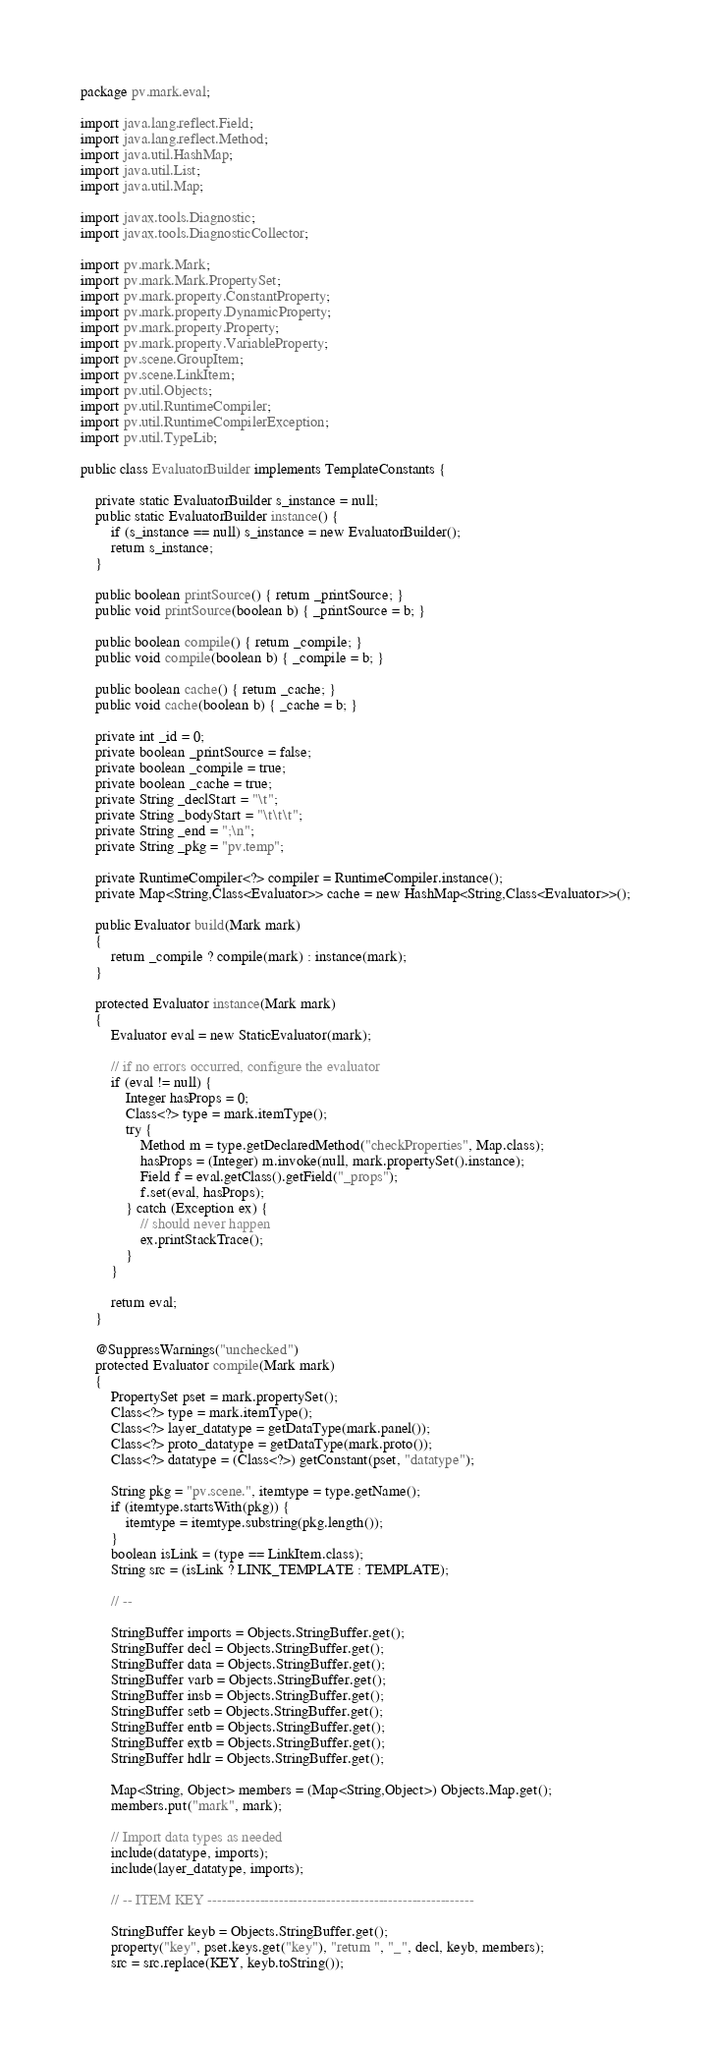Convert code to text. <code><loc_0><loc_0><loc_500><loc_500><_Java_>package pv.mark.eval;

import java.lang.reflect.Field;
import java.lang.reflect.Method;
import java.util.HashMap;
import java.util.List;
import java.util.Map;

import javax.tools.Diagnostic;
import javax.tools.DiagnosticCollector;

import pv.mark.Mark;
import pv.mark.Mark.PropertySet;
import pv.mark.property.ConstantProperty;
import pv.mark.property.DynamicProperty;
import pv.mark.property.Property;
import pv.mark.property.VariableProperty;
import pv.scene.GroupItem;
import pv.scene.LinkItem;
import pv.util.Objects;
import pv.util.RuntimeCompiler;
import pv.util.RuntimeCompilerException;
import pv.util.TypeLib;

public class EvaluatorBuilder implements TemplateConstants {
	
	private static EvaluatorBuilder s_instance = null;
	public static EvaluatorBuilder instance() {
		if (s_instance == null) s_instance = new EvaluatorBuilder();
		return s_instance;
	}
	
	public boolean printSource() { return _printSource; }
	public void printSource(boolean b) { _printSource = b; }
	
	public boolean compile() { return _compile; }
	public void compile(boolean b) { _compile = b; }
	
	public boolean cache() { return _cache; }
	public void cache(boolean b) { _cache = b; }
	
	private int _id = 0;
	private boolean _printSource = false;
	private boolean _compile = true;
	private boolean _cache = true;
	private String _declStart = "\t";
	private String _bodyStart = "\t\t\t";
	private String _end = ";\n";
	private String _pkg = "pv.temp";
	
	private RuntimeCompiler<?> compiler = RuntimeCompiler.instance();
	private Map<String,Class<Evaluator>> cache = new HashMap<String,Class<Evaluator>>();
	
	public Evaluator build(Mark mark)
	{
		return _compile ? compile(mark) : instance(mark);
	}
	
	protected Evaluator instance(Mark mark)
	{
		Evaluator eval = new StaticEvaluator(mark);
		
		// if no errors occurred, configure the evaluator
		if (eval != null) {
			Integer hasProps = 0;
			Class<?> type = mark.itemType();
			try {
				Method m = type.getDeclaredMethod("checkProperties", Map.class);
				hasProps = (Integer) m.invoke(null, mark.propertySet().instance);
				Field f = eval.getClass().getField("_props");
				f.set(eval, hasProps);
			} catch (Exception ex) {
				// should never happen
				ex.printStackTrace();
			}
		}
		
		return eval;
	}
	
	@SuppressWarnings("unchecked")
	protected Evaluator compile(Mark mark)
	{
		PropertySet pset = mark.propertySet();
		Class<?> type = mark.itemType();
		Class<?> layer_datatype = getDataType(mark.panel());
		Class<?> proto_datatype = getDataType(mark.proto());
		Class<?> datatype = (Class<?>) getConstant(pset, "datatype");
		
		String pkg = "pv.scene.", itemtype = type.getName();
		if (itemtype.startsWith(pkg)) {
			itemtype = itemtype.substring(pkg.length());
		}
		boolean isLink = (type == LinkItem.class);
		String src = (isLink ? LINK_TEMPLATE : TEMPLATE);
		
		// --
		
		StringBuffer imports = Objects.StringBuffer.get();
		StringBuffer decl = Objects.StringBuffer.get();
		StringBuffer data = Objects.StringBuffer.get();
		StringBuffer varb = Objects.StringBuffer.get();
		StringBuffer insb = Objects.StringBuffer.get();
		StringBuffer setb = Objects.StringBuffer.get();
		StringBuffer entb = Objects.StringBuffer.get();
		StringBuffer extb = Objects.StringBuffer.get();
		StringBuffer hdlr = Objects.StringBuffer.get();
		
		Map<String, Object> members = (Map<String,Object>) Objects.Map.get();
		members.put("mark", mark);
		
		// Import data types as needed
		include(datatype, imports);
		include(layer_datatype, imports);
		
		// -- ITEM KEY --------------------------------------------------------
		
		StringBuffer keyb = Objects.StringBuffer.get();
		property("key", pset.keys.get("key"), "return ", "_", decl, keyb, members);
		src = src.replace(KEY, keyb.toString());</code> 